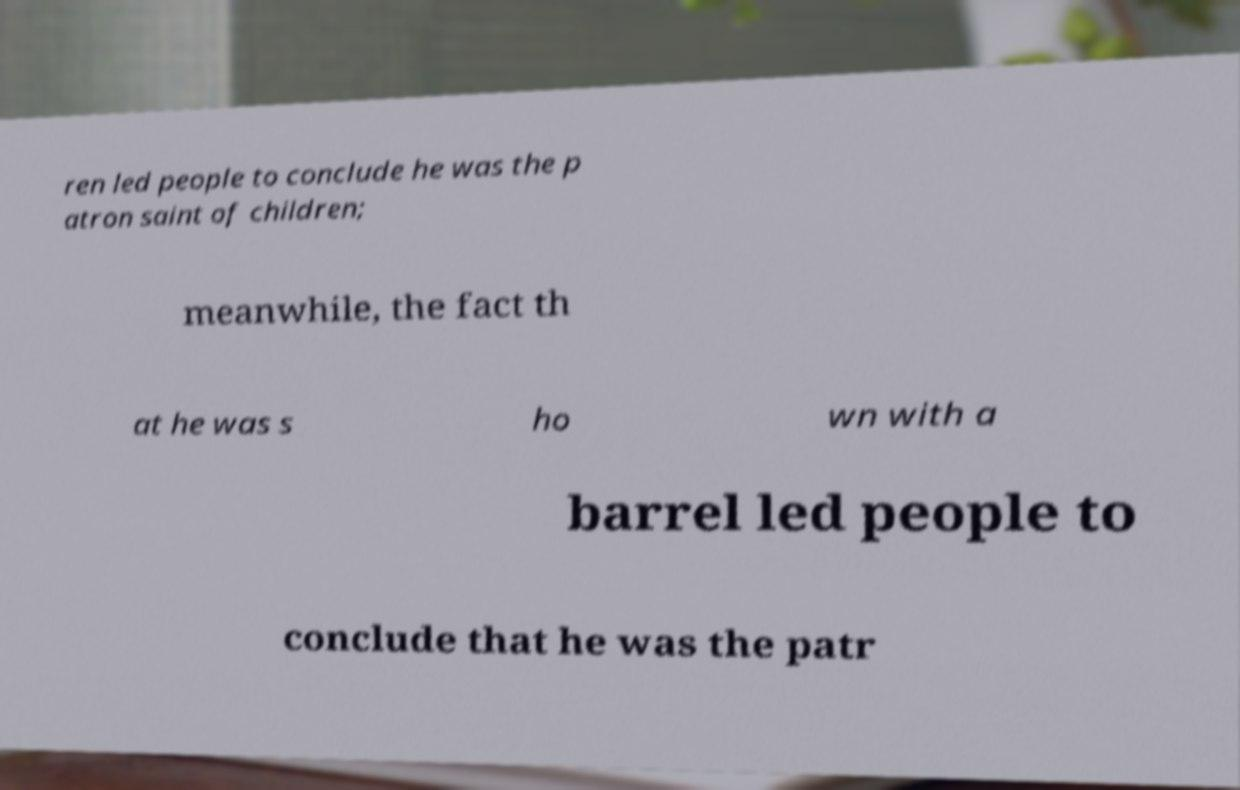Can you accurately transcribe the text from the provided image for me? ren led people to conclude he was the p atron saint of children; meanwhile, the fact th at he was s ho wn with a barrel led people to conclude that he was the patr 